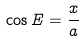Convert formula to latex. <formula><loc_0><loc_0><loc_500><loc_500>\cos E = \frac { x } { a }</formula> 